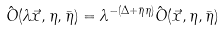Convert formula to latex. <formula><loc_0><loc_0><loc_500><loc_500>\hat { O } ( \lambda \vec { x } , \eta , \bar { \eta } ) = \lambda ^ { - ( \Delta + \bar { \eta } \eta ) } \hat { O } ( \vec { x } , \eta , \bar { \eta } )</formula> 